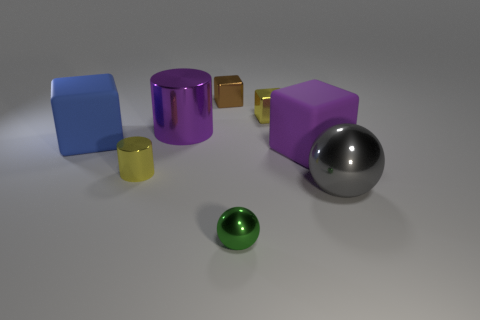Subtract all big purple blocks. How many blocks are left? 3 Add 2 blue metal spheres. How many objects exist? 10 Subtract all purple cubes. How many cubes are left? 3 Subtract all cylinders. How many objects are left? 6 Subtract 1 cylinders. How many cylinders are left? 1 Subtract all blue blocks. Subtract all blue spheres. How many blocks are left? 3 Subtract all green metallic balls. Subtract all big metallic things. How many objects are left? 5 Add 5 small shiny balls. How many small shiny balls are left? 6 Add 3 large matte cubes. How many large matte cubes exist? 5 Subtract 0 brown cylinders. How many objects are left? 8 